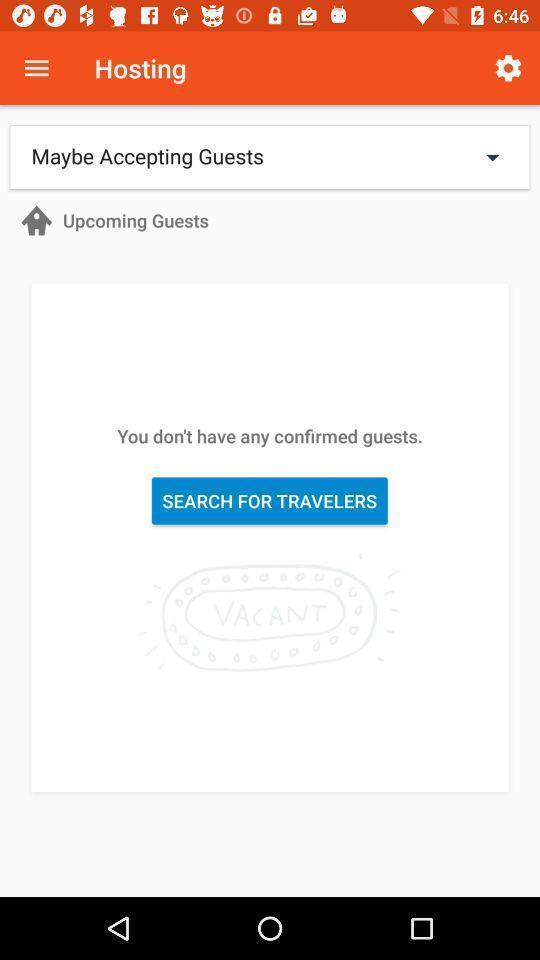Describe the content in this image. Page showing details about guests on an app. 